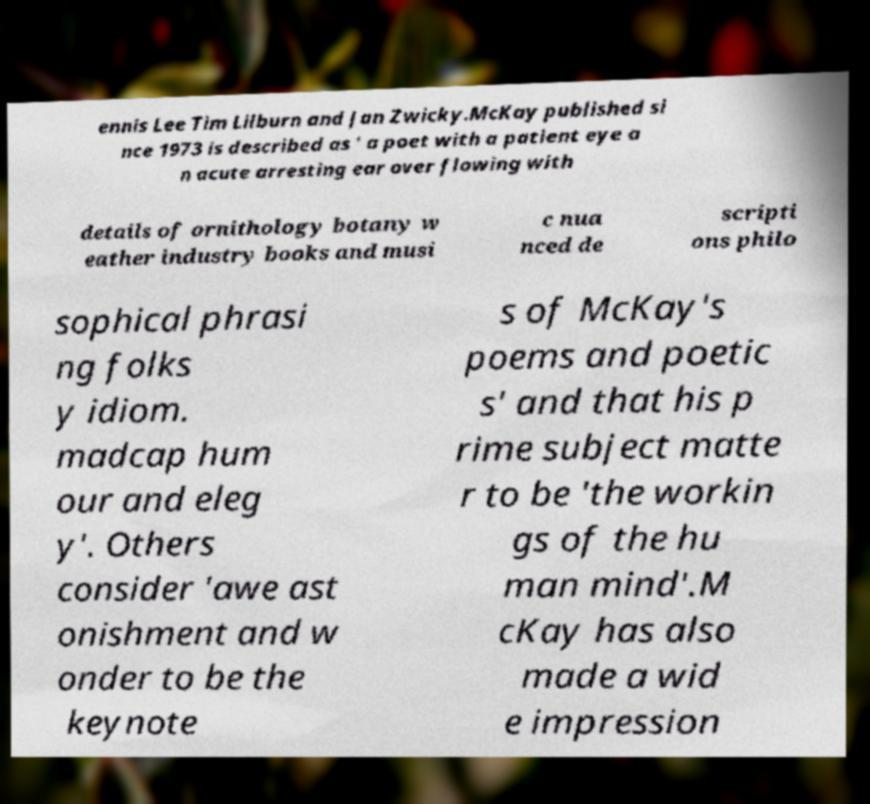I need the written content from this picture converted into text. Can you do that? ennis Lee Tim Lilburn and Jan Zwicky.McKay published si nce 1973 is described as ' a poet with a patient eye a n acute arresting ear over flowing with details of ornithology botany w eather industry books and musi c nua nced de scripti ons philo sophical phrasi ng folks y idiom. madcap hum our and eleg y'. Others consider 'awe ast onishment and w onder to be the keynote s of McKay's poems and poetic s' and that his p rime subject matte r to be 'the workin gs of the hu man mind'.M cKay has also made a wid e impression 